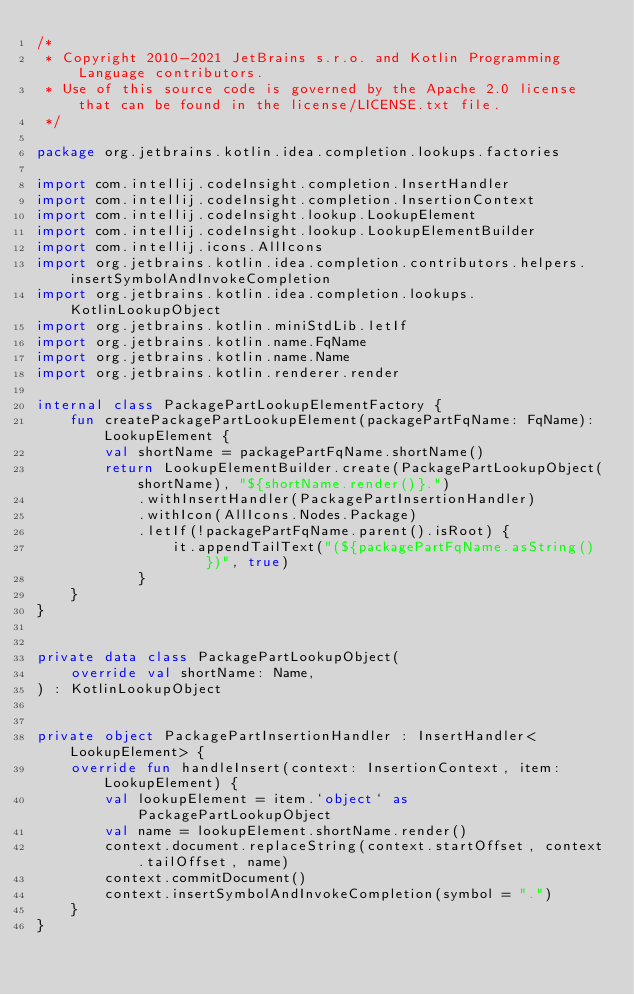Convert code to text. <code><loc_0><loc_0><loc_500><loc_500><_Kotlin_>/*
 * Copyright 2010-2021 JetBrains s.r.o. and Kotlin Programming Language contributors.
 * Use of this source code is governed by the Apache 2.0 license that can be found in the license/LICENSE.txt file.
 */

package org.jetbrains.kotlin.idea.completion.lookups.factories

import com.intellij.codeInsight.completion.InsertHandler
import com.intellij.codeInsight.completion.InsertionContext
import com.intellij.codeInsight.lookup.LookupElement
import com.intellij.codeInsight.lookup.LookupElementBuilder
import com.intellij.icons.AllIcons
import org.jetbrains.kotlin.idea.completion.contributors.helpers.insertSymbolAndInvokeCompletion
import org.jetbrains.kotlin.idea.completion.lookups.KotlinLookupObject
import org.jetbrains.kotlin.miniStdLib.letIf
import org.jetbrains.kotlin.name.FqName
import org.jetbrains.kotlin.name.Name
import org.jetbrains.kotlin.renderer.render

internal class PackagePartLookupElementFactory {
    fun createPackagePartLookupElement(packagePartFqName: FqName): LookupElement {
        val shortName = packagePartFqName.shortName()
        return LookupElementBuilder.create(PackagePartLookupObject(shortName), "${shortName.render()}.")
            .withInsertHandler(PackagePartInsertionHandler)
            .withIcon(AllIcons.Nodes.Package)
            .letIf(!packagePartFqName.parent().isRoot) {
                it.appendTailText("(${packagePartFqName.asString()})", true)
            }
    }
}


private data class PackagePartLookupObject(
    override val shortName: Name,
) : KotlinLookupObject


private object PackagePartInsertionHandler : InsertHandler<LookupElement> {
    override fun handleInsert(context: InsertionContext, item: LookupElement) {
        val lookupElement = item.`object` as PackagePartLookupObject
        val name = lookupElement.shortName.render()
        context.document.replaceString(context.startOffset, context.tailOffset, name)
        context.commitDocument()
        context.insertSymbolAndInvokeCompletion(symbol = ".")
    }
}

</code> 